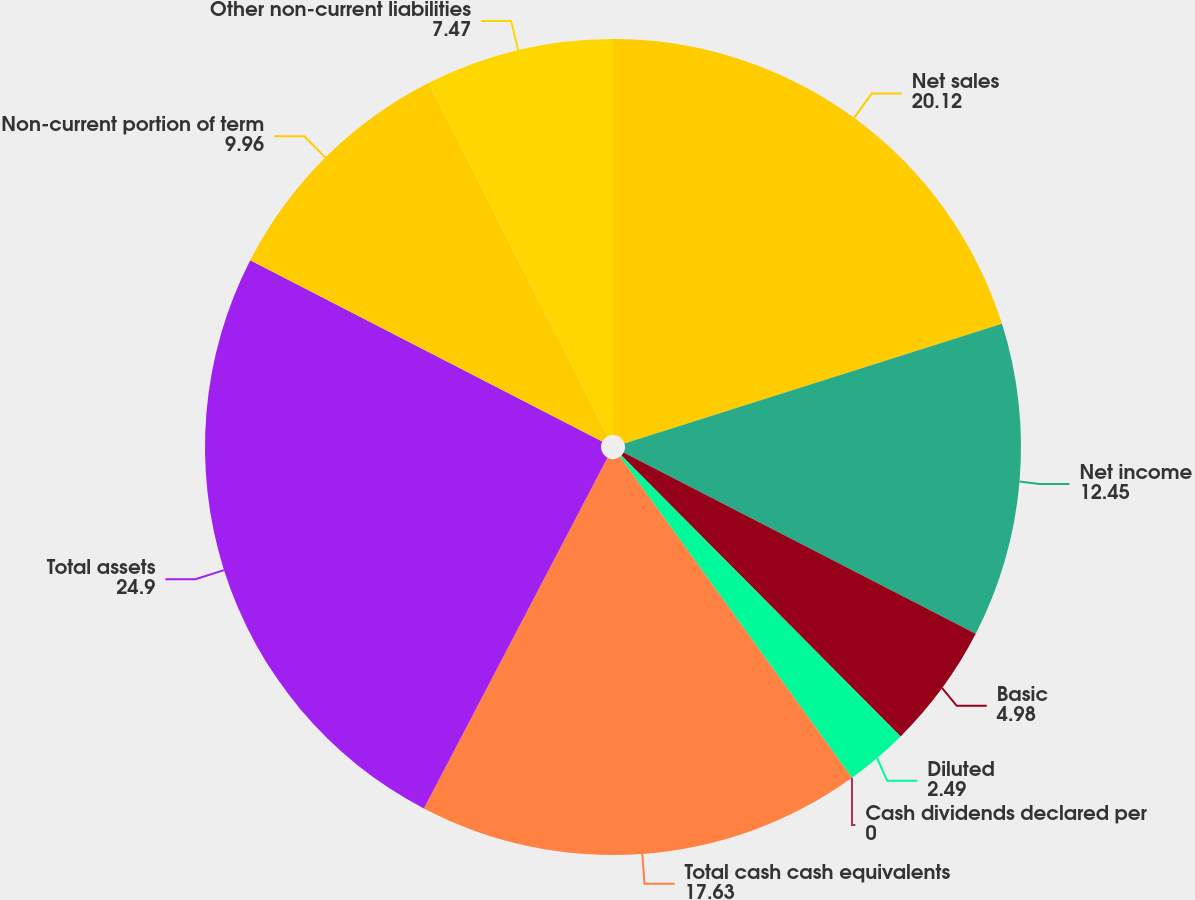Convert chart. <chart><loc_0><loc_0><loc_500><loc_500><pie_chart><fcel>Net sales<fcel>Net income<fcel>Basic<fcel>Diluted<fcel>Cash dividends declared per<fcel>Total cash cash equivalents<fcel>Total assets<fcel>Non-current portion of term<fcel>Other non-current liabilities<nl><fcel>20.12%<fcel>12.45%<fcel>4.98%<fcel>2.49%<fcel>0.0%<fcel>17.63%<fcel>24.9%<fcel>9.96%<fcel>7.47%<nl></chart> 